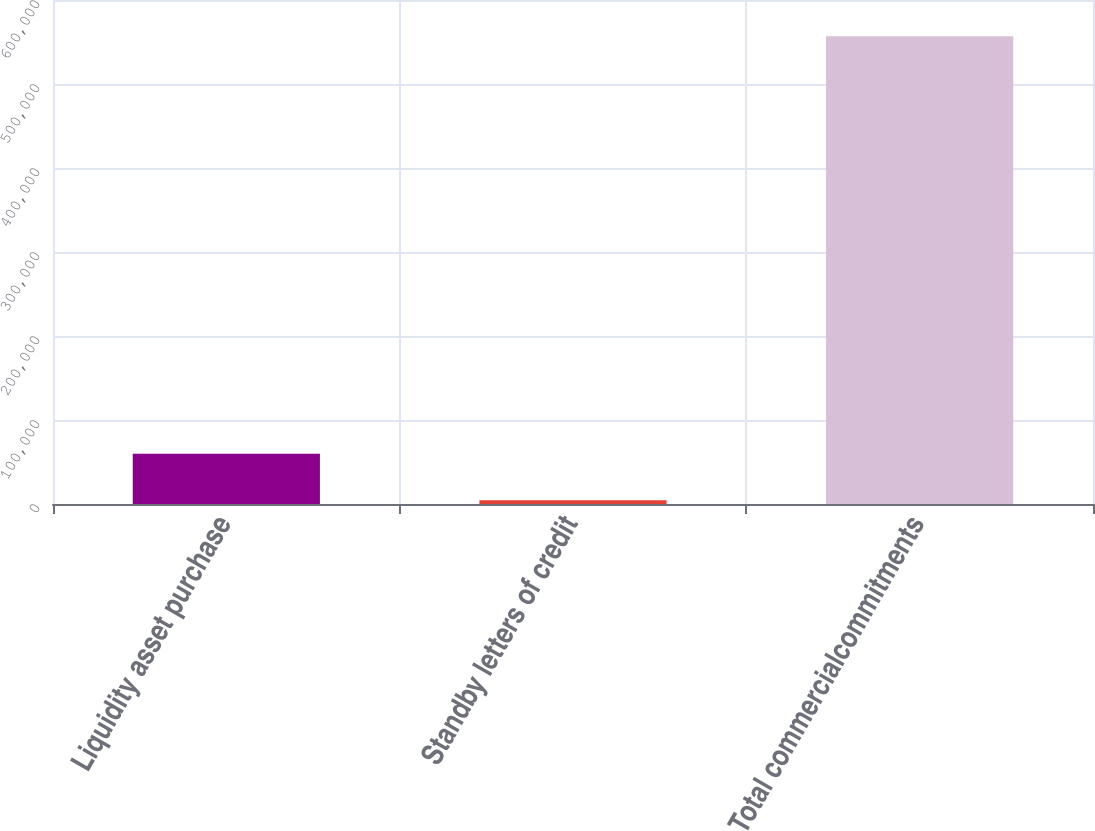<chart> <loc_0><loc_0><loc_500><loc_500><bar_chart><fcel>Liquidity asset purchase<fcel>Standby letters of credit<fcel>Total commercialcommitments<nl><fcel>59677.3<fcel>4437<fcel>556840<nl></chart> 